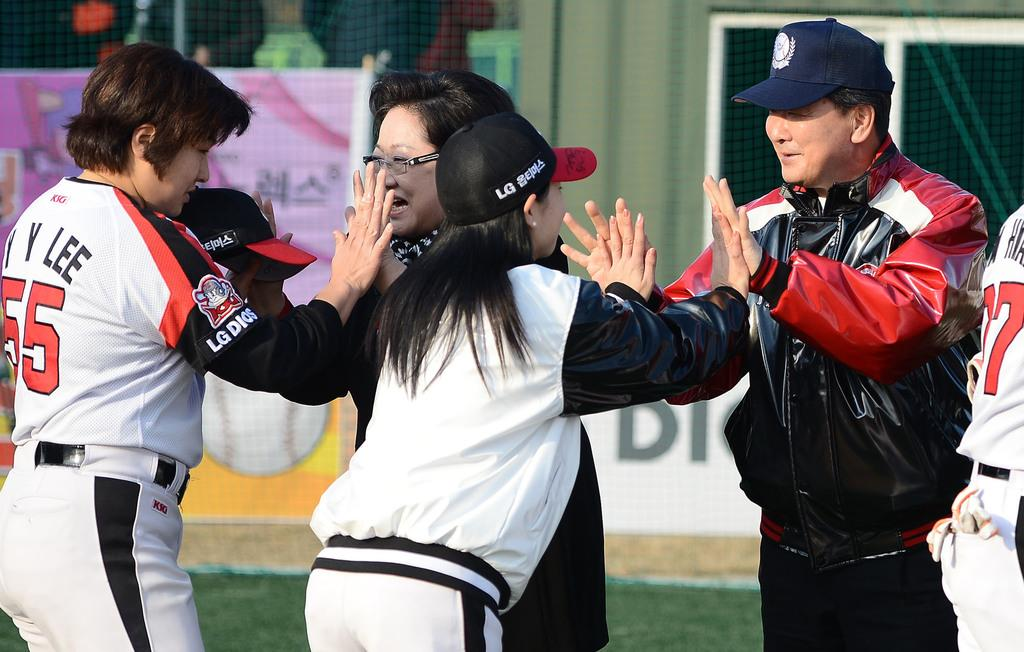Provide a one-sentence caption for the provided image. A Baseball team giving each other high fives, their shirts display LG DIOS. 